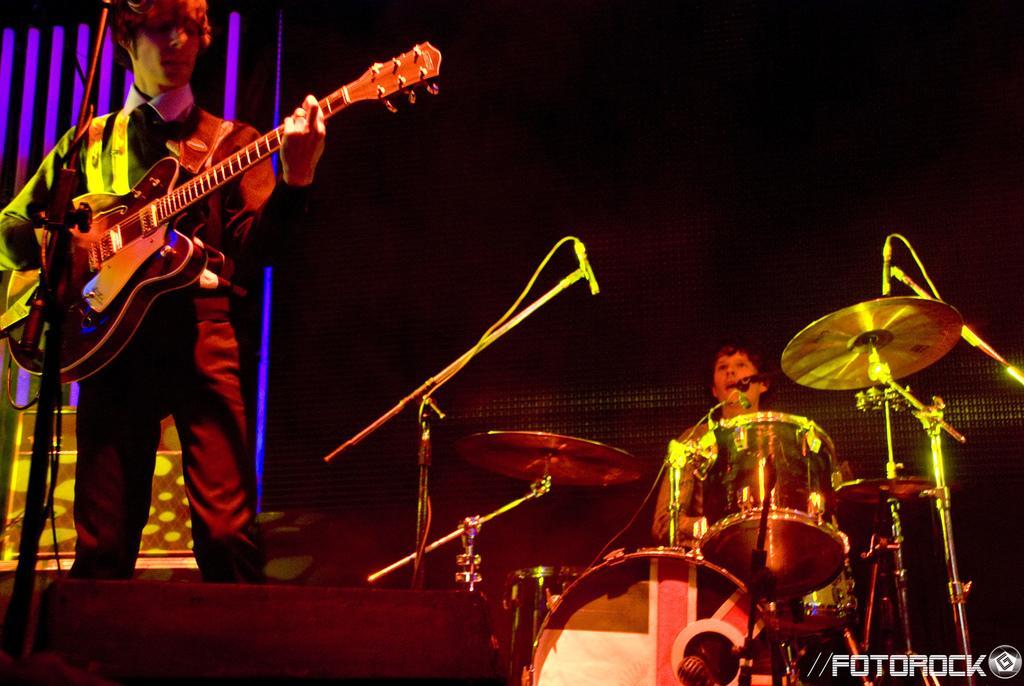In one or two sentences, can you explain what this image depicts? This is the stage where a person is standing and holding a guitar in his hands. This man on the right side is playing the electronic drums. 